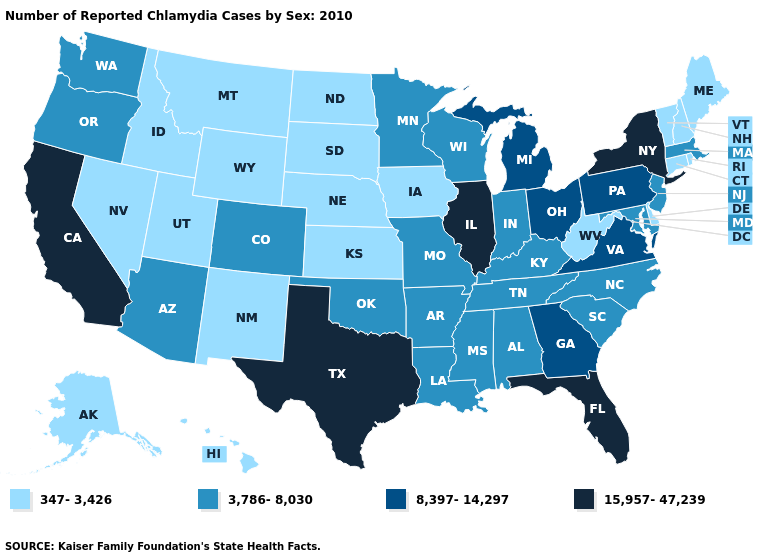What is the highest value in the USA?
Give a very brief answer. 15,957-47,239. Does California have the lowest value in the West?
Write a very short answer. No. What is the highest value in the Northeast ?
Keep it brief. 15,957-47,239. Name the states that have a value in the range 15,957-47,239?
Be succinct. California, Florida, Illinois, New York, Texas. Which states have the highest value in the USA?
Be succinct. California, Florida, Illinois, New York, Texas. What is the lowest value in the South?
Keep it brief. 347-3,426. Does Hawaii have a higher value than Rhode Island?
Keep it brief. No. What is the value of Maine?
Keep it brief. 347-3,426. What is the lowest value in the USA?
Answer briefly. 347-3,426. What is the value of New Mexico?
Keep it brief. 347-3,426. Which states have the lowest value in the West?
Give a very brief answer. Alaska, Hawaii, Idaho, Montana, Nevada, New Mexico, Utah, Wyoming. Among the states that border Alabama , which have the lowest value?
Write a very short answer. Mississippi, Tennessee. Name the states that have a value in the range 347-3,426?
Concise answer only. Alaska, Connecticut, Delaware, Hawaii, Idaho, Iowa, Kansas, Maine, Montana, Nebraska, Nevada, New Hampshire, New Mexico, North Dakota, Rhode Island, South Dakota, Utah, Vermont, West Virginia, Wyoming. How many symbols are there in the legend?
Give a very brief answer. 4. Does West Virginia have the lowest value in the South?
Concise answer only. Yes. 